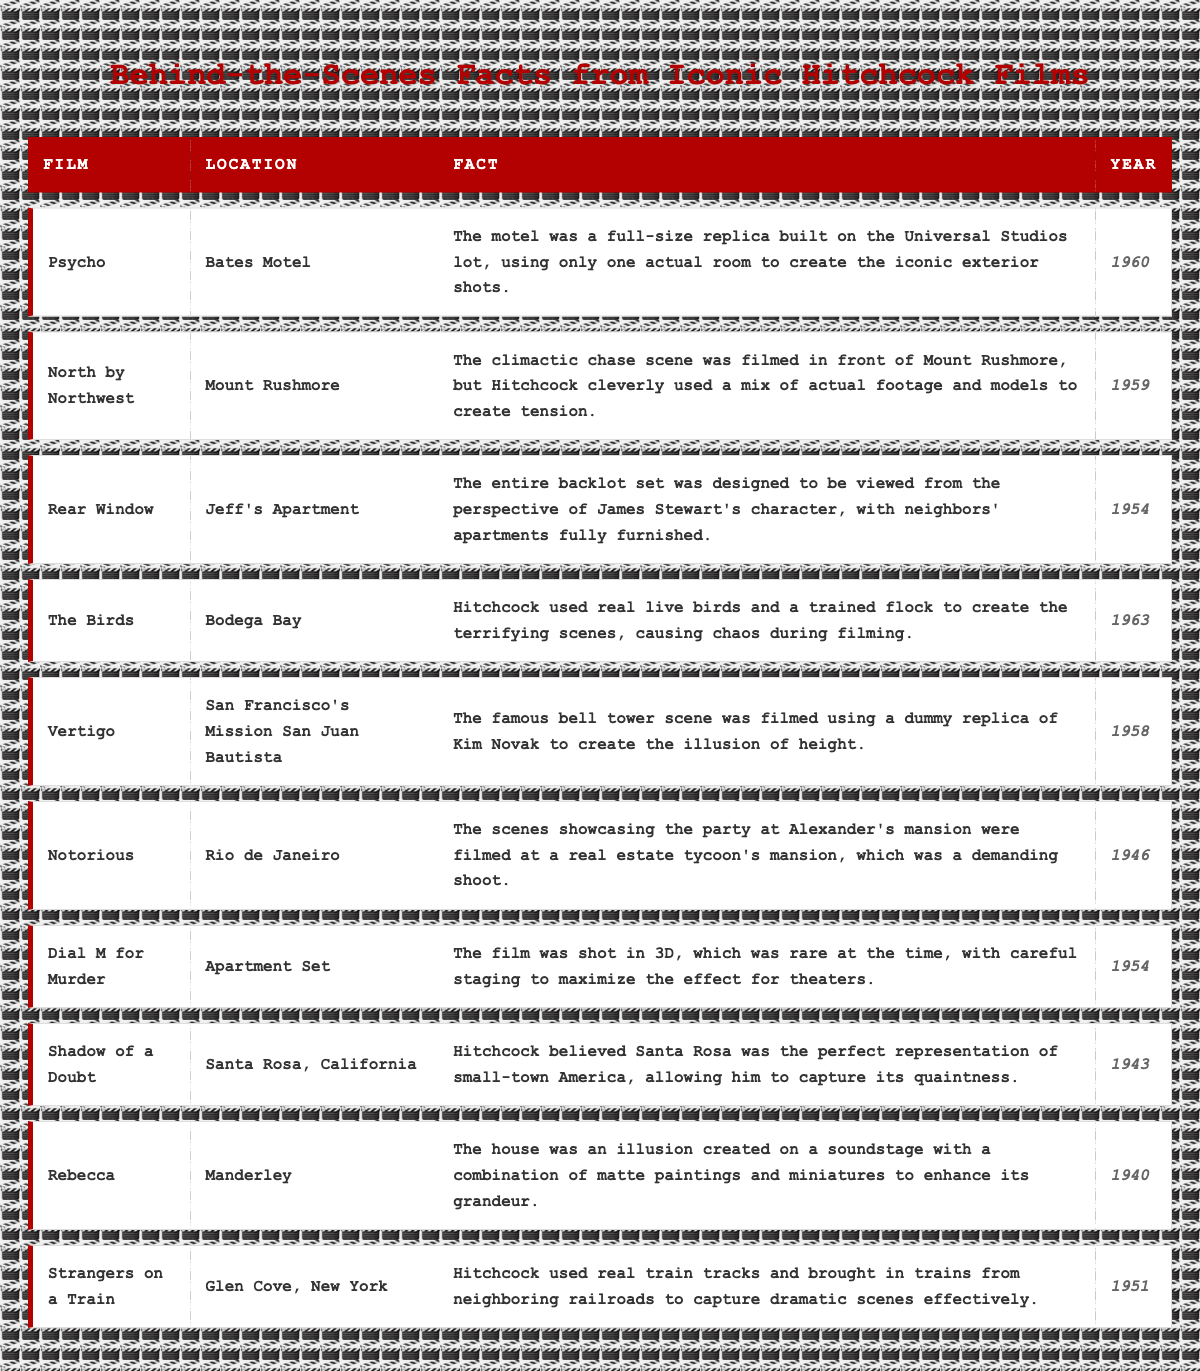What year was "The Birds" released? By looking at the table, I can find the film "The Birds" under the "Film" column and see that the "Year" column for it is 1963.
Answer: 1963 Which film was shot in Rio de Janeiro? In the "Location" column, I find "Rio de Janeiro" associated with the film "Notorious."
Answer: Notorious How many films were released before 1950? I will count the films listed before 1950 in the table: "Rebecca" (1940), "Shadow of a Doubt" (1943), and "Notorious" (1946), which totals 3.
Answer: 3 Did "Vertigo" use a real actor in the bell tower scene? The fact listed for "Vertigo" indicates that a dummy replica of Kim Novak was used, which means a real actor was not used for that scene.
Answer: No What location appears in the most recent film from the table? The most recent film listed in the table is "The Birds" from 1963, and its location is "Bodega Bay."
Answer: Bodega Bay What is the unique characteristic of the set used for "Rear Window"? The fact for "Rear Window" describes the backlot set as designed to be viewed from James Stewart's perspective, including fully furnished neighbors' apartments.
Answer: It was designed from James Stewart's perspective Which film's fact mentions the use of real live birds? Looking through the "Fact" column, "The Birds" contains a fact about using real live birds, specifically stating that Hitchcock caused chaos during filming.
Answer: The Birds Which two films were shot in the same year, 1954? From the table, I see that both "Rear Window" and "Dial M for Murder" have the year 1954 in the "Year" column.
Answer: Rear Window and Dial M for Murder What was the filming technique used in "Dial M for Murder"? The fact for "Dial M for Murder" states that it was shot in 3D, which is a notable filming technique for the time.
Answer: 3D filming Which film features Mount Rushmore? The table notes that "North by Northwest" features Mount Rushmore as its filming location.
Answer: North by Northwest What commonality do "Shadow of a Doubt" and "Notorious" share based on their locations? Both films are set in locations that represent small-town America and exotic locations, respectively, showcasing a contrast in themes.
Answer: Different themes Which film has a location described as an illusion created on a soundstage? The description for "Rebecca" specifies that Manderley was created as an illusion on a soundstage using matte paintings and miniatures.
Answer: Rebecca 